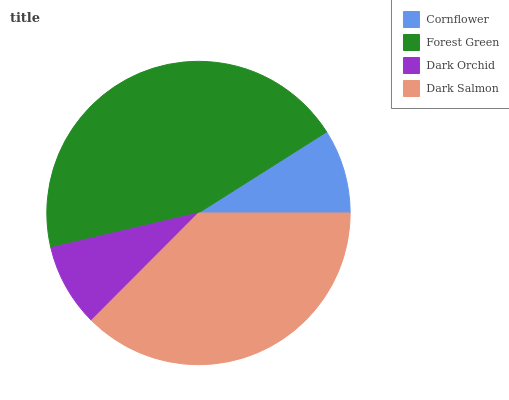Is Dark Orchid the minimum?
Answer yes or no. Yes. Is Forest Green the maximum?
Answer yes or no. Yes. Is Forest Green the minimum?
Answer yes or no. No. Is Dark Orchid the maximum?
Answer yes or no. No. Is Forest Green greater than Dark Orchid?
Answer yes or no. Yes. Is Dark Orchid less than Forest Green?
Answer yes or no. Yes. Is Dark Orchid greater than Forest Green?
Answer yes or no. No. Is Forest Green less than Dark Orchid?
Answer yes or no. No. Is Dark Salmon the high median?
Answer yes or no. Yes. Is Cornflower the low median?
Answer yes or no. Yes. Is Cornflower the high median?
Answer yes or no. No. Is Dark Orchid the low median?
Answer yes or no. No. 